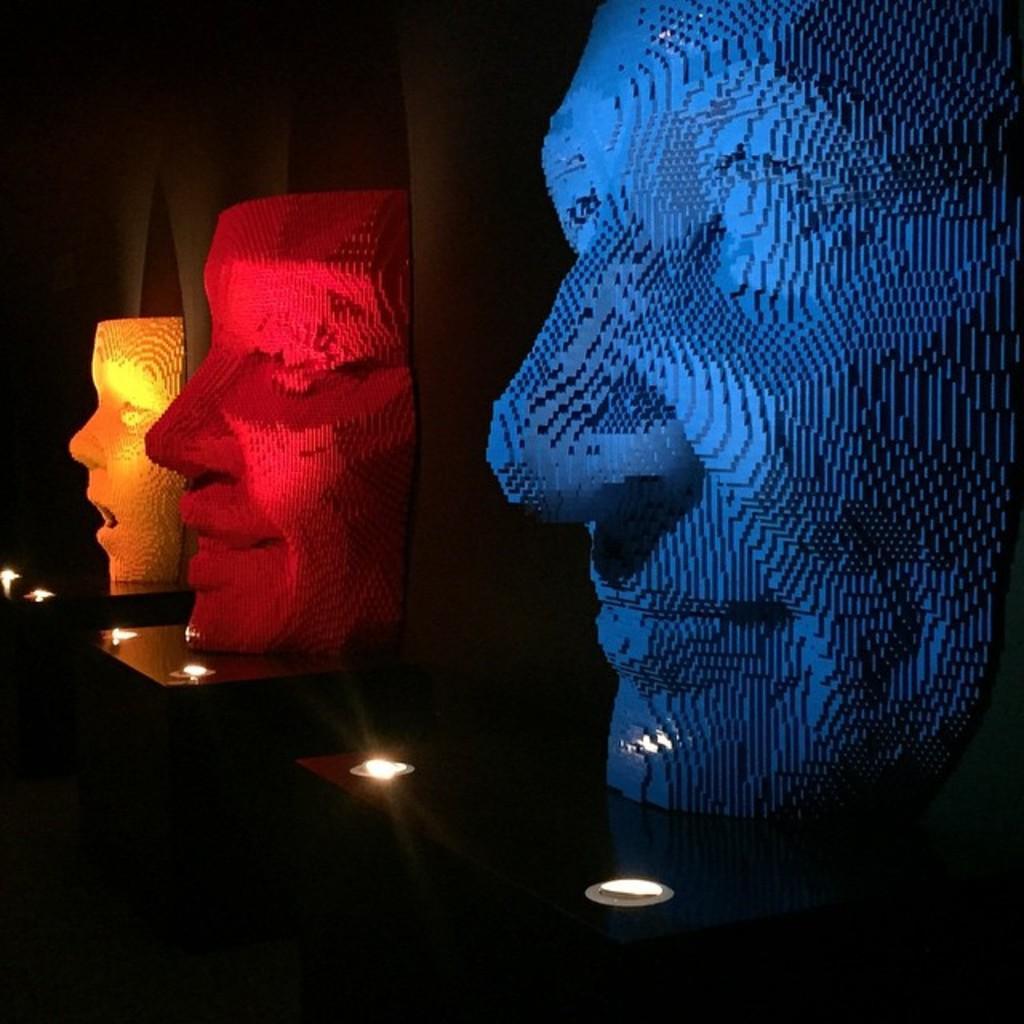In one or two sentences, can you explain what this image depicts? In the image there are colorful statues of faces with different expressions and there are two lights in front of each sculpture. 